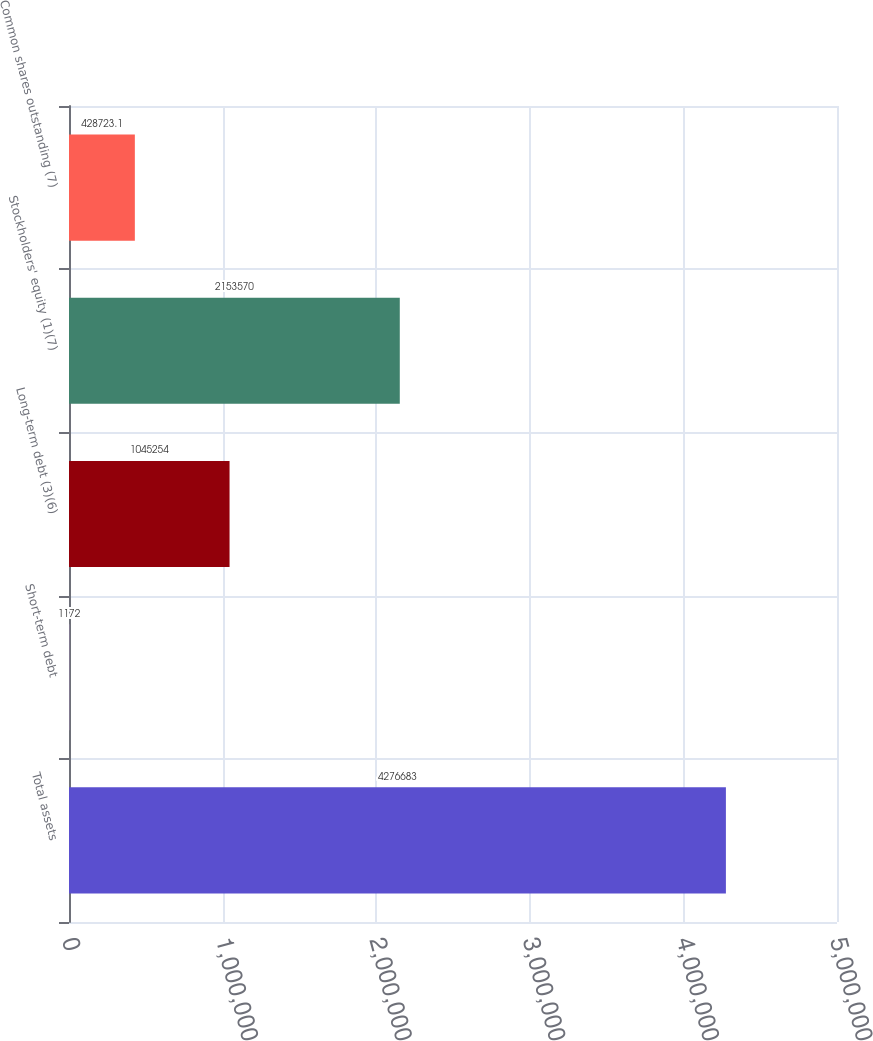Convert chart to OTSL. <chart><loc_0><loc_0><loc_500><loc_500><bar_chart><fcel>Total assets<fcel>Short-term debt<fcel>Long-term debt (3)(6)<fcel>Stockholders' equity (1)(7)<fcel>Common shares outstanding (7)<nl><fcel>4.27668e+06<fcel>1172<fcel>1.04525e+06<fcel>2.15357e+06<fcel>428723<nl></chart> 